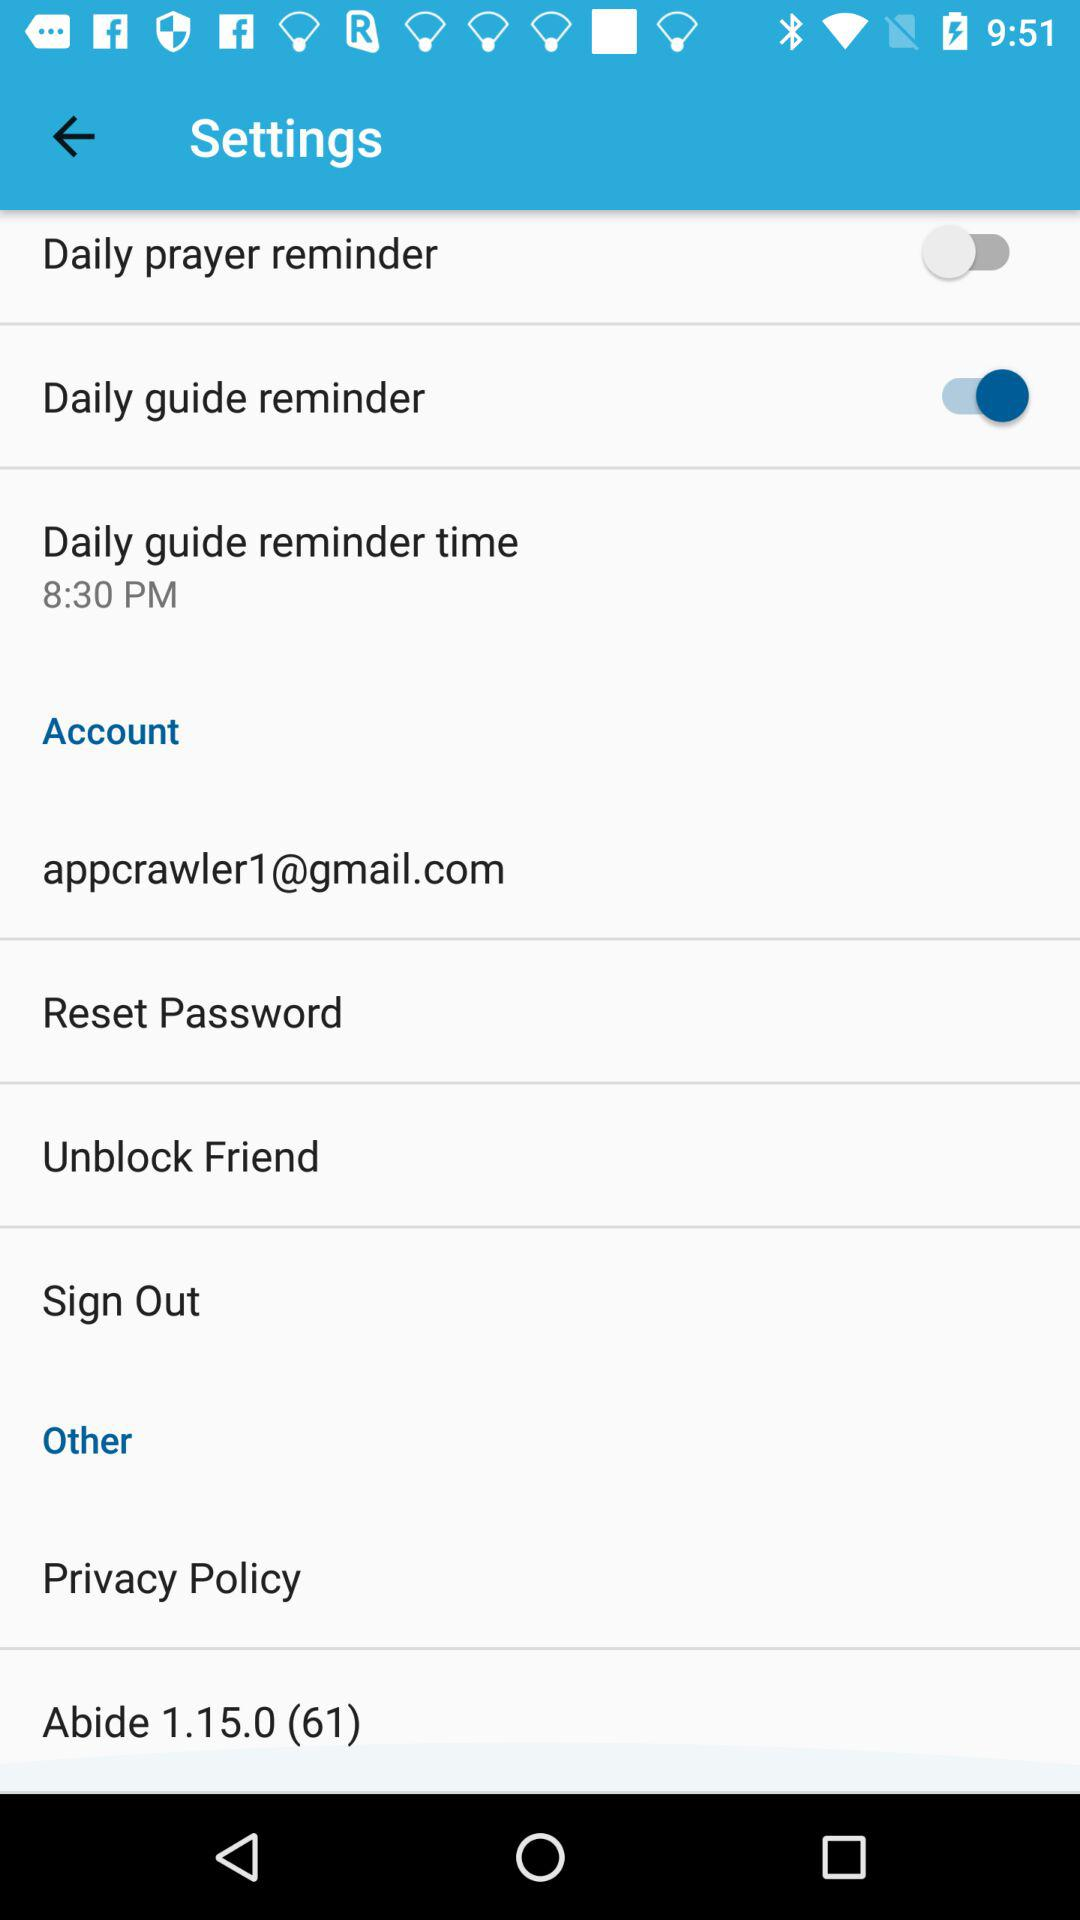What is the status of the "Daily prayer reminder"? The status is "off". 